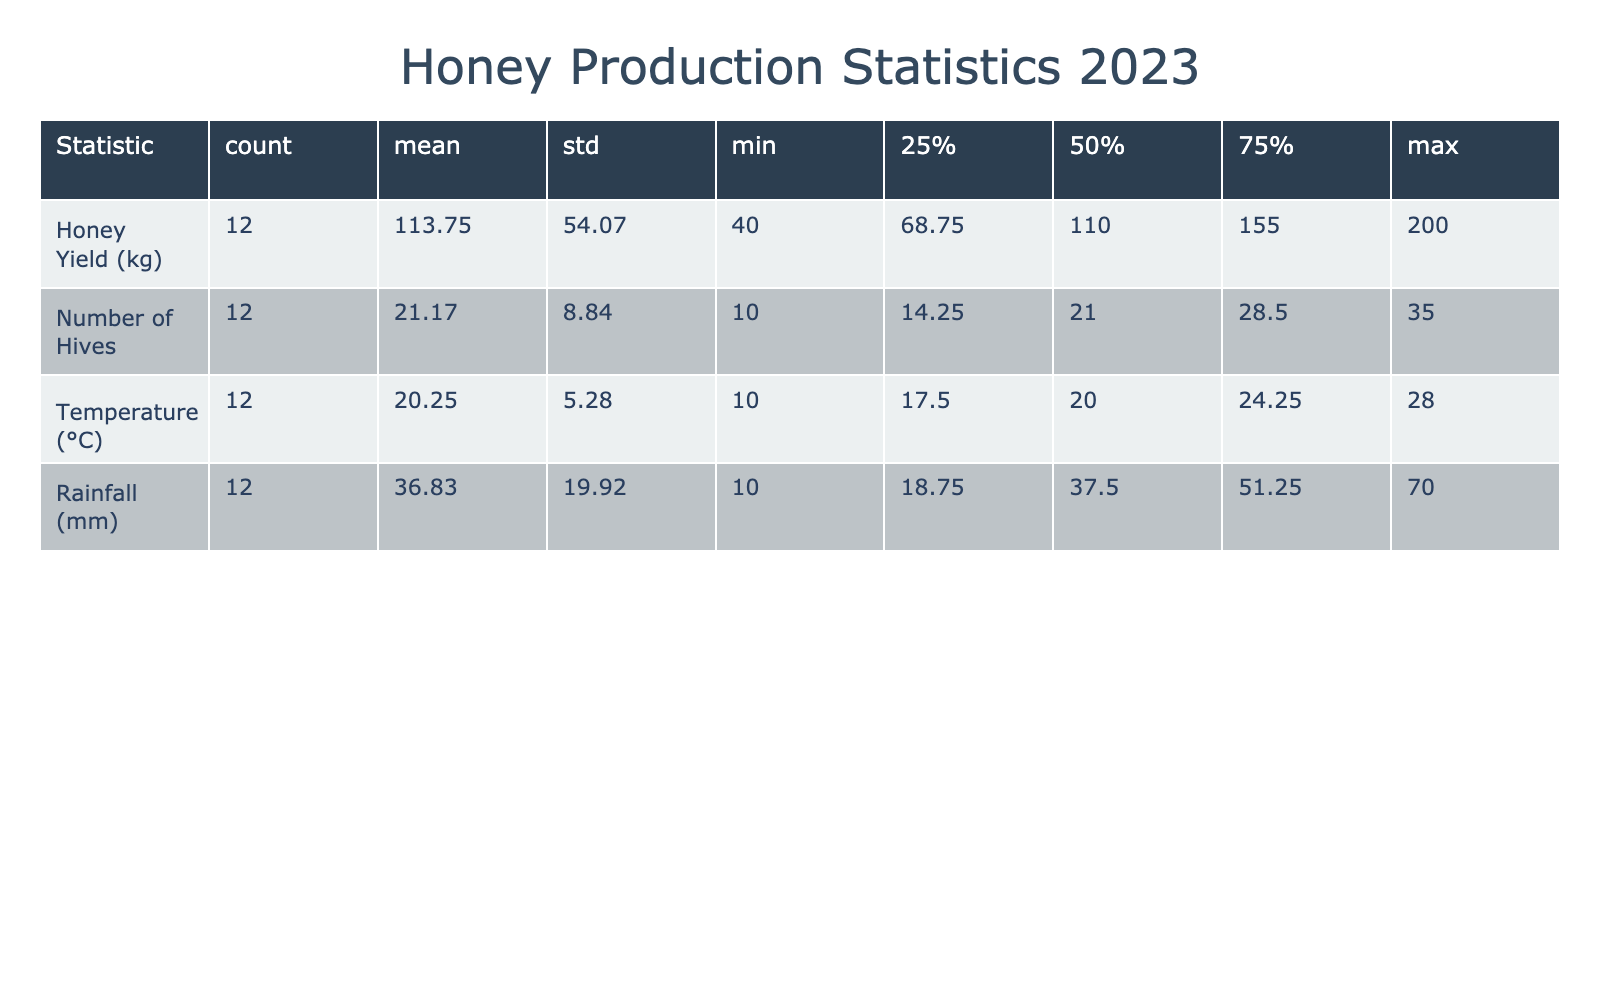What was the honey yield in June? The table lists the honey yields by month. For June, it shows the yield as 180 kg from Wildflower Hollow APIary.
Answer: 180 kg Which month had the highest honey yield? By examining the honey yields listed, July shows the highest yield at 200 kg from Mountain View Apiary.
Answer: July What is the average honey yield for the months from January to March? The yields from January to March are 50 kg, 65 kg, and 80 kg respectively. We sum these values (50 + 65 + 80 = 195) and divide by the number of months (3). Therefore, the average yield is 195/3 = 65 kg.
Answer: 65 kg Is there a correlation between temperature and honey yield in the table? Generally, as the temperature increases, the honey yield also increases. However, deeper statistical analysis could confirm the correlation, but based on observation, higher temperatures seem to align with higher yields.
Answer: Yes What was the total honey yield for the period between May and September? The yields from May to September are 150 kg, 180 kg, 200 kg, 170 kg, and 140 kg, respectively. Summing these values gives (150 + 180 + 200 + 170 + 140) = 840 kg as the total yield for these months.
Answer: 840 kg How many hives were there in October? The table specifically lists October with 22 hives at Lakeside Apiary. Therefore, we can directly refer to this value.
Answer: 22 hives What was the highest rainfall recorded in a month? By scanning the rainfall column, December has the highest recorded rainfall at 70 mm.
Answer: 70 mm What is the average number of hives used across all months? The total number of hives is the sum of 10, 12, 15, 20, 25, 30, 35, 32, 28, 22, 15, and 10 which totals  10 + 12 + 15 + 20 + 25 + 30 + 35 + 32 + 28 + 22 + 15 + 10 =  10. This gives us an average of 10/12 (number of months) =  22.5 hives.
Answer: 22.5 hives 